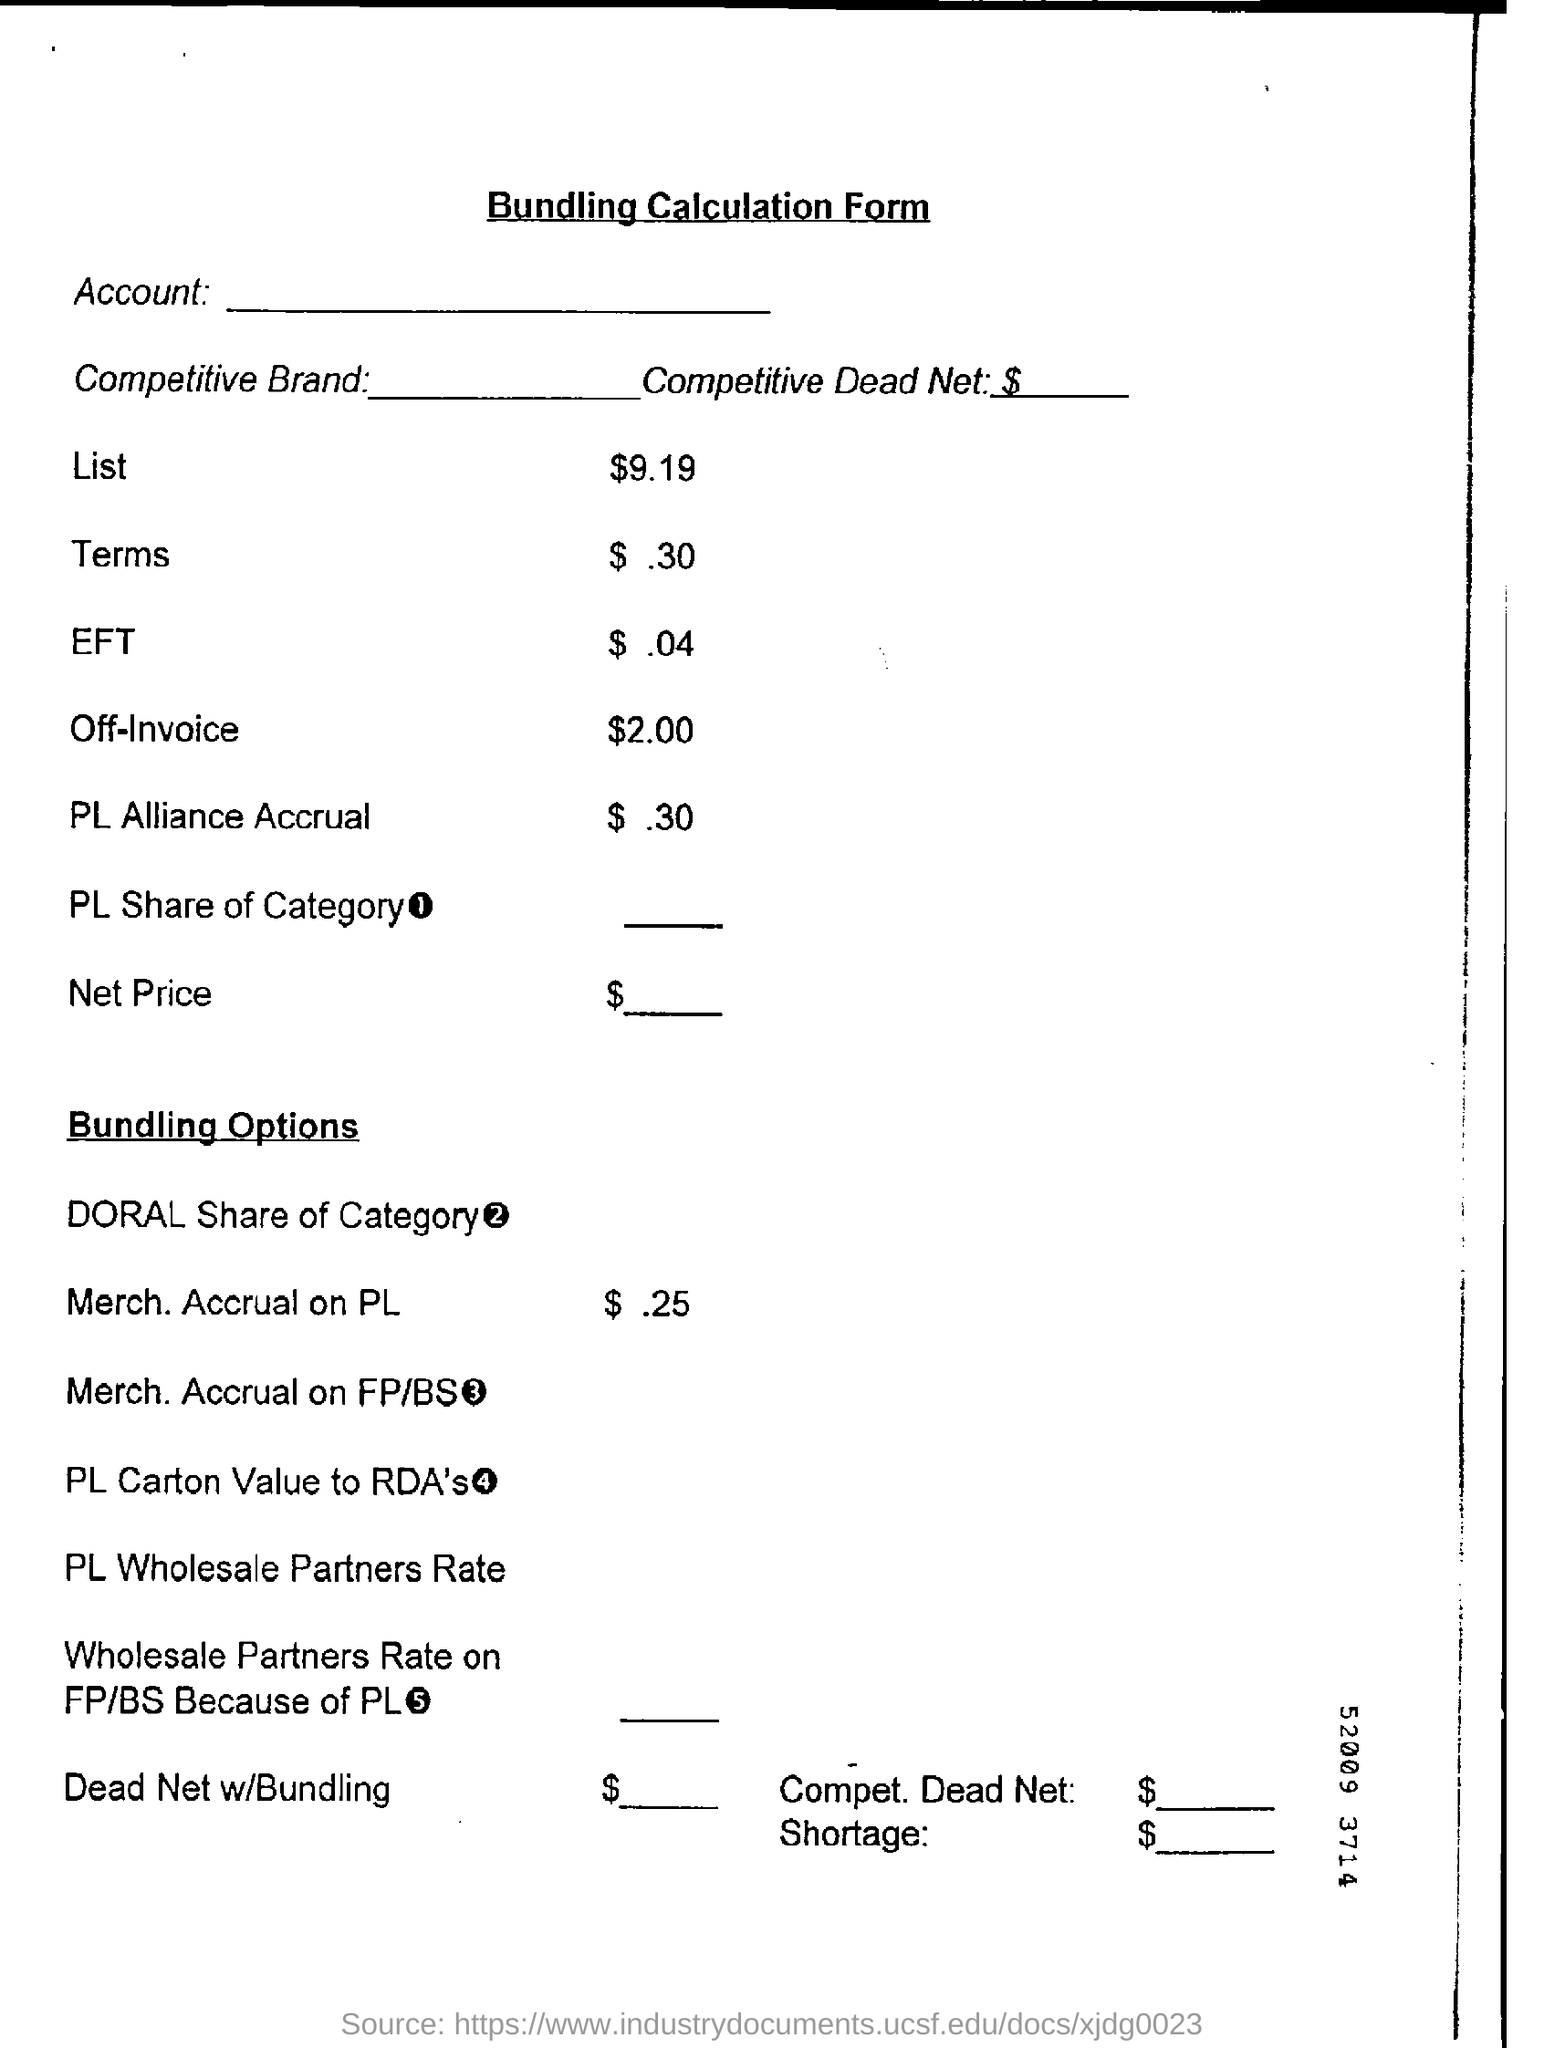Indicate a few pertinent items in this graphic. The document is titled "Bundling Calculation Form. 